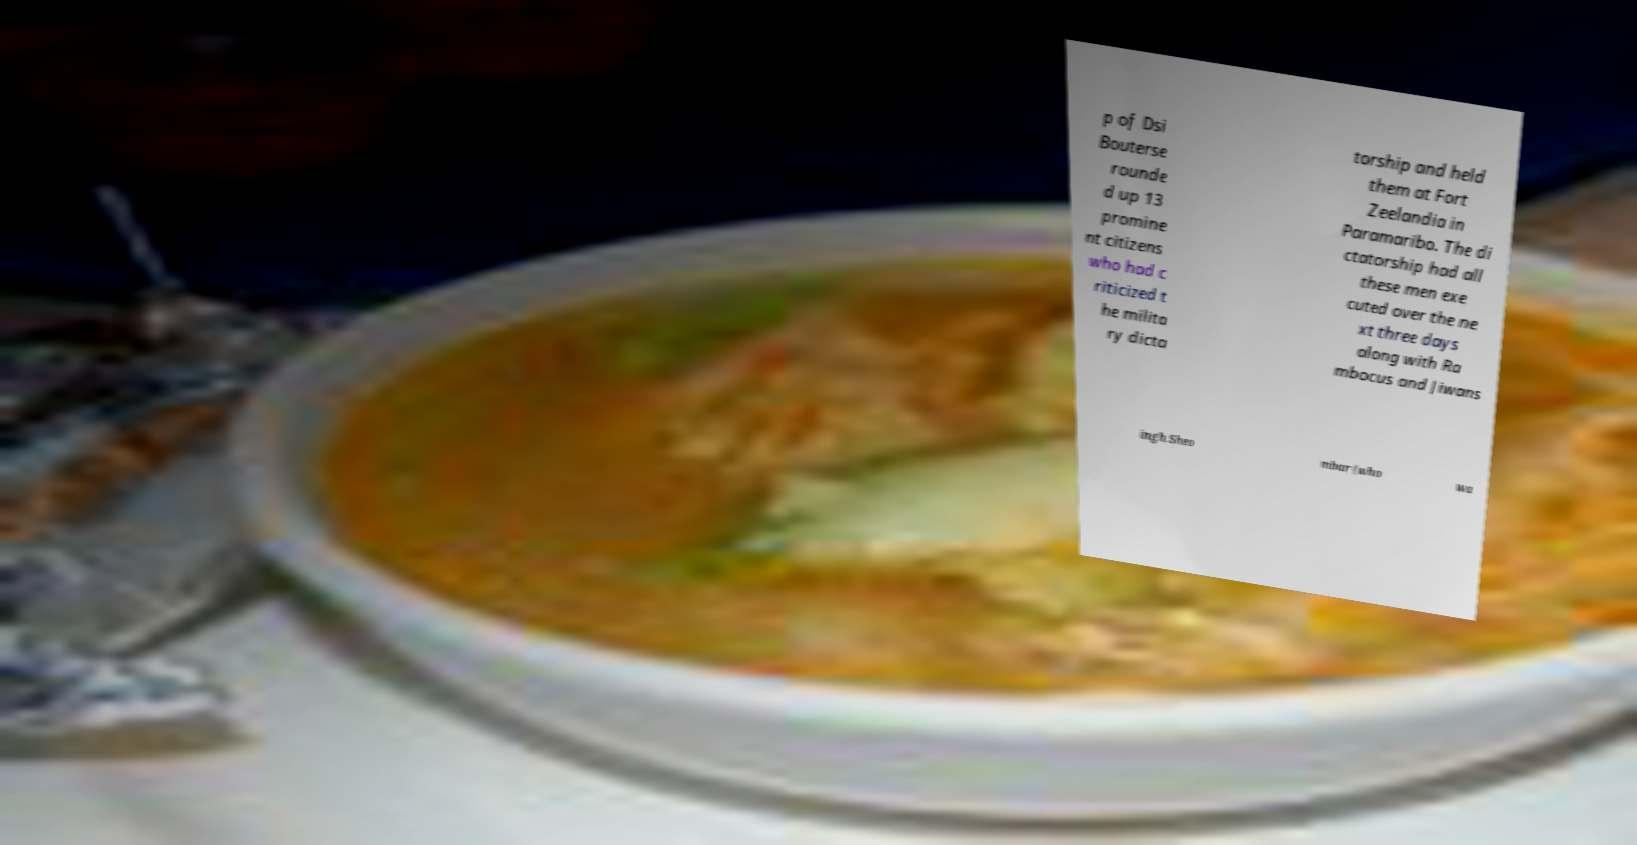Please identify and transcribe the text found in this image. p of Dsi Bouterse rounde d up 13 promine nt citizens who had c riticized t he milita ry dicta torship and held them at Fort Zeelandia in Paramaribo. The di ctatorship had all these men exe cuted over the ne xt three days along with Ra mbocus and Jiwans ingh Sheo mbar (who wa 